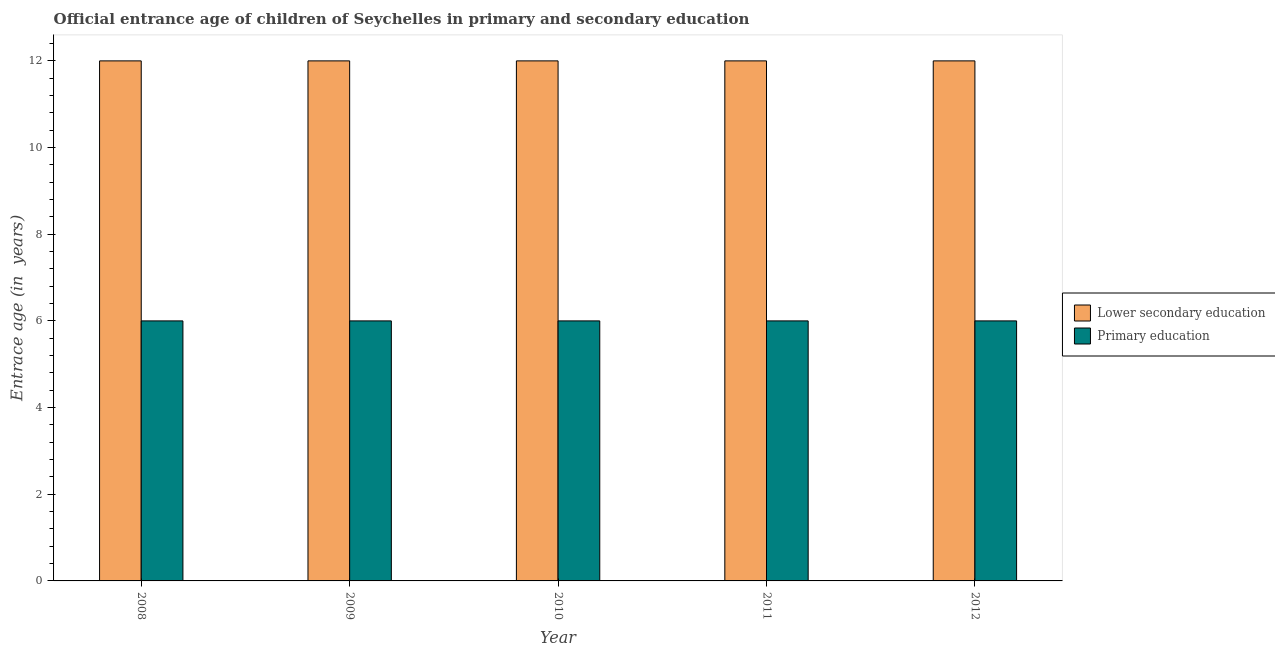How many groups of bars are there?
Make the answer very short. 5. Are the number of bars per tick equal to the number of legend labels?
Make the answer very short. Yes. Are the number of bars on each tick of the X-axis equal?
Offer a terse response. Yes. How many bars are there on the 1st tick from the left?
Give a very brief answer. 2. What is the label of the 4th group of bars from the left?
Provide a succinct answer. 2011. What is the entrance age of children in lower secondary education in 2012?
Offer a very short reply. 12. Across all years, what is the maximum entrance age of chiildren in primary education?
Give a very brief answer. 6. Across all years, what is the minimum entrance age of chiildren in primary education?
Make the answer very short. 6. In which year was the entrance age of children in lower secondary education maximum?
Your answer should be compact. 2008. In which year was the entrance age of children in lower secondary education minimum?
Provide a short and direct response. 2008. What is the total entrance age of children in lower secondary education in the graph?
Give a very brief answer. 60. What is the difference between the entrance age of children in lower secondary education in 2011 and the entrance age of chiildren in primary education in 2010?
Provide a short and direct response. 0. In the year 2010, what is the difference between the entrance age of children in lower secondary education and entrance age of chiildren in primary education?
Offer a terse response. 0. What is the ratio of the entrance age of chiildren in primary education in 2009 to that in 2010?
Provide a succinct answer. 1. Is the entrance age of chiildren in primary education in 2011 less than that in 2012?
Give a very brief answer. No. Is the difference between the entrance age of chiildren in primary education in 2010 and 2012 greater than the difference between the entrance age of children in lower secondary education in 2010 and 2012?
Offer a very short reply. No. What is the difference between the highest and the second highest entrance age of children in lower secondary education?
Your answer should be very brief. 0. In how many years, is the entrance age of chiildren in primary education greater than the average entrance age of chiildren in primary education taken over all years?
Your response must be concise. 0. Is the sum of the entrance age of chiildren in primary education in 2008 and 2010 greater than the maximum entrance age of children in lower secondary education across all years?
Give a very brief answer. Yes. How many bars are there?
Keep it short and to the point. 10. Are all the bars in the graph horizontal?
Your answer should be compact. No. How many years are there in the graph?
Offer a terse response. 5. Are the values on the major ticks of Y-axis written in scientific E-notation?
Provide a short and direct response. No. Does the graph contain any zero values?
Offer a very short reply. No. How are the legend labels stacked?
Make the answer very short. Vertical. What is the title of the graph?
Your answer should be compact. Official entrance age of children of Seychelles in primary and secondary education. What is the label or title of the X-axis?
Your response must be concise. Year. What is the label or title of the Y-axis?
Make the answer very short. Entrace age (in  years). What is the Entrace age (in  years) of Lower secondary education in 2008?
Provide a succinct answer. 12. What is the Entrace age (in  years) in Primary education in 2010?
Keep it short and to the point. 6. What is the Entrace age (in  years) in Primary education in 2011?
Your answer should be very brief. 6. What is the Entrace age (in  years) in Lower secondary education in 2012?
Offer a terse response. 12. Across all years, what is the maximum Entrace age (in  years) in Lower secondary education?
Keep it short and to the point. 12. Across all years, what is the maximum Entrace age (in  years) in Primary education?
Give a very brief answer. 6. Across all years, what is the minimum Entrace age (in  years) in Lower secondary education?
Give a very brief answer. 12. What is the total Entrace age (in  years) of Primary education in the graph?
Keep it short and to the point. 30. What is the difference between the Entrace age (in  years) of Primary education in 2008 and that in 2009?
Provide a short and direct response. 0. What is the difference between the Entrace age (in  years) of Lower secondary education in 2008 and that in 2010?
Your answer should be compact. 0. What is the difference between the Entrace age (in  years) of Primary education in 2008 and that in 2010?
Your response must be concise. 0. What is the difference between the Entrace age (in  years) of Lower secondary education in 2008 and that in 2011?
Provide a short and direct response. 0. What is the difference between the Entrace age (in  years) in Primary education in 2008 and that in 2011?
Your response must be concise. 0. What is the difference between the Entrace age (in  years) in Primary education in 2009 and that in 2010?
Ensure brevity in your answer.  0. What is the difference between the Entrace age (in  years) of Lower secondary education in 2009 and that in 2012?
Your response must be concise. 0. What is the difference between the Entrace age (in  years) of Lower secondary education in 2010 and that in 2011?
Keep it short and to the point. 0. What is the difference between the Entrace age (in  years) in Lower secondary education in 2011 and that in 2012?
Your response must be concise. 0. What is the difference between the Entrace age (in  years) in Primary education in 2011 and that in 2012?
Provide a short and direct response. 0. What is the difference between the Entrace age (in  years) of Lower secondary education in 2008 and the Entrace age (in  years) of Primary education in 2012?
Ensure brevity in your answer.  6. What is the difference between the Entrace age (in  years) of Lower secondary education in 2011 and the Entrace age (in  years) of Primary education in 2012?
Give a very brief answer. 6. What is the average Entrace age (in  years) of Lower secondary education per year?
Make the answer very short. 12. What is the average Entrace age (in  years) in Primary education per year?
Ensure brevity in your answer.  6. In the year 2008, what is the difference between the Entrace age (in  years) of Lower secondary education and Entrace age (in  years) of Primary education?
Your answer should be compact. 6. In the year 2009, what is the difference between the Entrace age (in  years) in Lower secondary education and Entrace age (in  years) in Primary education?
Keep it short and to the point. 6. In the year 2010, what is the difference between the Entrace age (in  years) in Lower secondary education and Entrace age (in  years) in Primary education?
Your answer should be very brief. 6. In the year 2011, what is the difference between the Entrace age (in  years) in Lower secondary education and Entrace age (in  years) in Primary education?
Make the answer very short. 6. In the year 2012, what is the difference between the Entrace age (in  years) of Lower secondary education and Entrace age (in  years) of Primary education?
Give a very brief answer. 6. What is the ratio of the Entrace age (in  years) in Primary education in 2008 to that in 2009?
Provide a short and direct response. 1. What is the ratio of the Entrace age (in  years) in Primary education in 2008 to that in 2010?
Give a very brief answer. 1. What is the ratio of the Entrace age (in  years) of Primary education in 2008 to that in 2012?
Make the answer very short. 1. What is the ratio of the Entrace age (in  years) in Lower secondary education in 2009 to that in 2010?
Provide a succinct answer. 1. What is the ratio of the Entrace age (in  years) of Primary education in 2009 to that in 2010?
Your answer should be compact. 1. What is the ratio of the Entrace age (in  years) in Lower secondary education in 2009 to that in 2011?
Provide a succinct answer. 1. What is the ratio of the Entrace age (in  years) of Lower secondary education in 2009 to that in 2012?
Your response must be concise. 1. What is the ratio of the Entrace age (in  years) of Primary education in 2009 to that in 2012?
Give a very brief answer. 1. What is the ratio of the Entrace age (in  years) in Primary education in 2010 to that in 2011?
Make the answer very short. 1. What is the ratio of the Entrace age (in  years) of Primary education in 2010 to that in 2012?
Keep it short and to the point. 1. What is the ratio of the Entrace age (in  years) of Lower secondary education in 2011 to that in 2012?
Your answer should be very brief. 1. What is the difference between the highest and the second highest Entrace age (in  years) in Lower secondary education?
Give a very brief answer. 0. What is the difference between the highest and the lowest Entrace age (in  years) of Lower secondary education?
Keep it short and to the point. 0. What is the difference between the highest and the lowest Entrace age (in  years) in Primary education?
Your answer should be very brief. 0. 